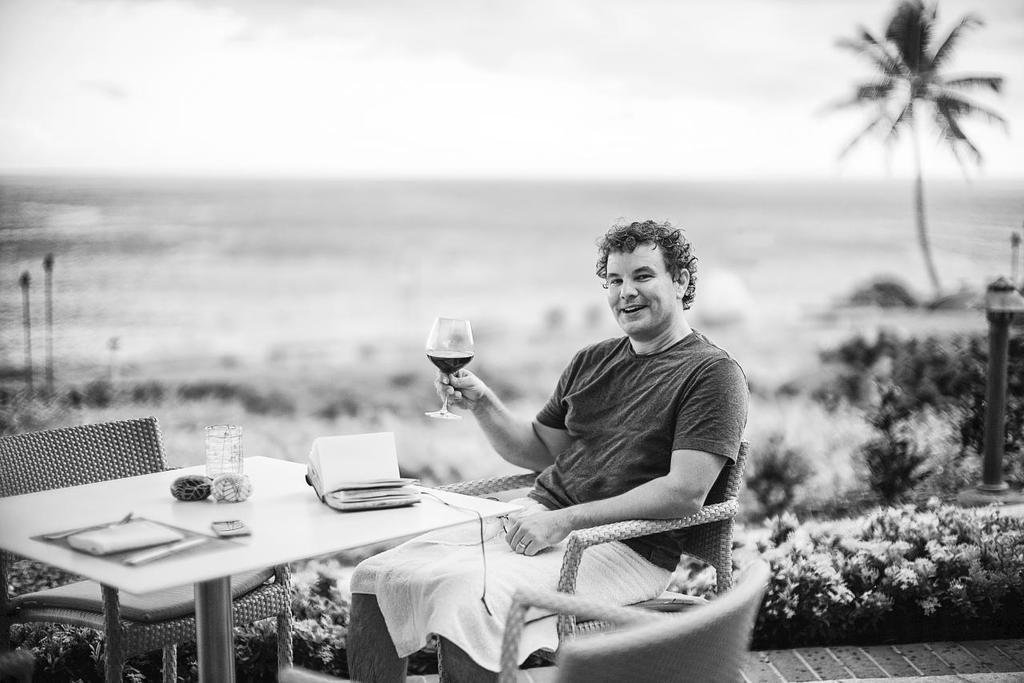Can you describe this image briefly? In this image, a person is sitting on the chair in front of the table and holding a glass in his hand, on which book, glass and soon kept. On the right, trees are visible and a pole is visible. On the top, a sky is visible of white in color. In the middle a ground is visible. This image is taken during day time in an open area. 